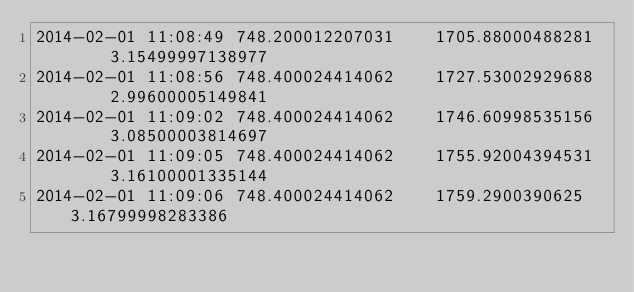Convert code to text. <code><loc_0><loc_0><loc_500><loc_500><_SQL_>2014-02-01 11:08:49	748.200012207031	1705.88000488281	3.15499997138977
2014-02-01 11:08:56	748.400024414062	1727.53002929688	2.99600005149841
2014-02-01 11:09:02	748.400024414062	1746.60998535156	3.08500003814697
2014-02-01 11:09:05	748.400024414062	1755.92004394531	3.16100001335144
2014-02-01 11:09:06	748.400024414062	1759.2900390625	3.16799998283386</code> 